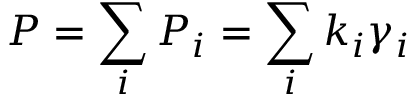<formula> <loc_0><loc_0><loc_500><loc_500>P = \sum _ { i } P _ { i } = \sum _ { i } k _ { i } \gamma _ { i }</formula> 